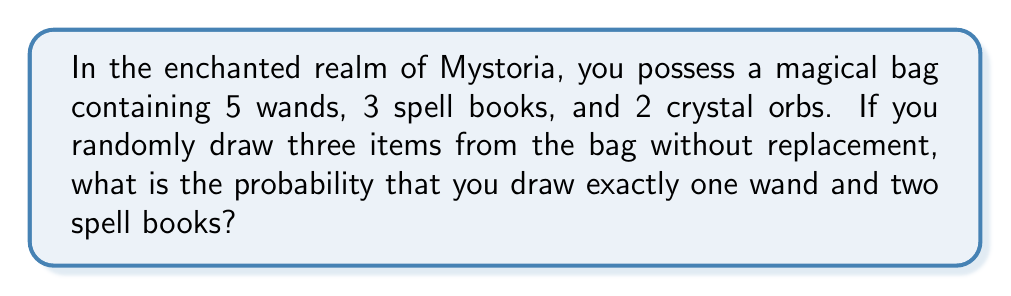Give your solution to this math problem. Let's approach this step-by-step using the concepts of combinatorics and probability:

1) First, we need to calculate the total number of ways to draw 3 items from 10 items. This is given by the combination formula:

   $$\binom{10}{3} = \frac{10!}{3!(10-3)!} = \frac{10!}{3!7!} = 120$$

2) Now, we need to calculate the number of ways to draw 1 wand and 2 spell books:
   - Choose 1 wand from 5 wands: $\binom{5}{1}$
   - Choose 2 spell books from 3 spell books: $\binom{3}{2}$

3) Multiply these together:

   $$\binom{5}{1} \cdot \binom{3}{2} = 5 \cdot 3 = 15$$

4) The probability is then the number of favorable outcomes divided by the total number of possible outcomes:

   $$P(\text{1 wand and 2 spell books}) = \frac{15}{120} = \frac{1}{8} = 0.125$$

Thus, the probability of drawing exactly one wand and two spell books is $\frac{1}{8}$ or 0.125 or 12.5%.
Answer: $\frac{1}{8}$ or 0.125 or 12.5% 